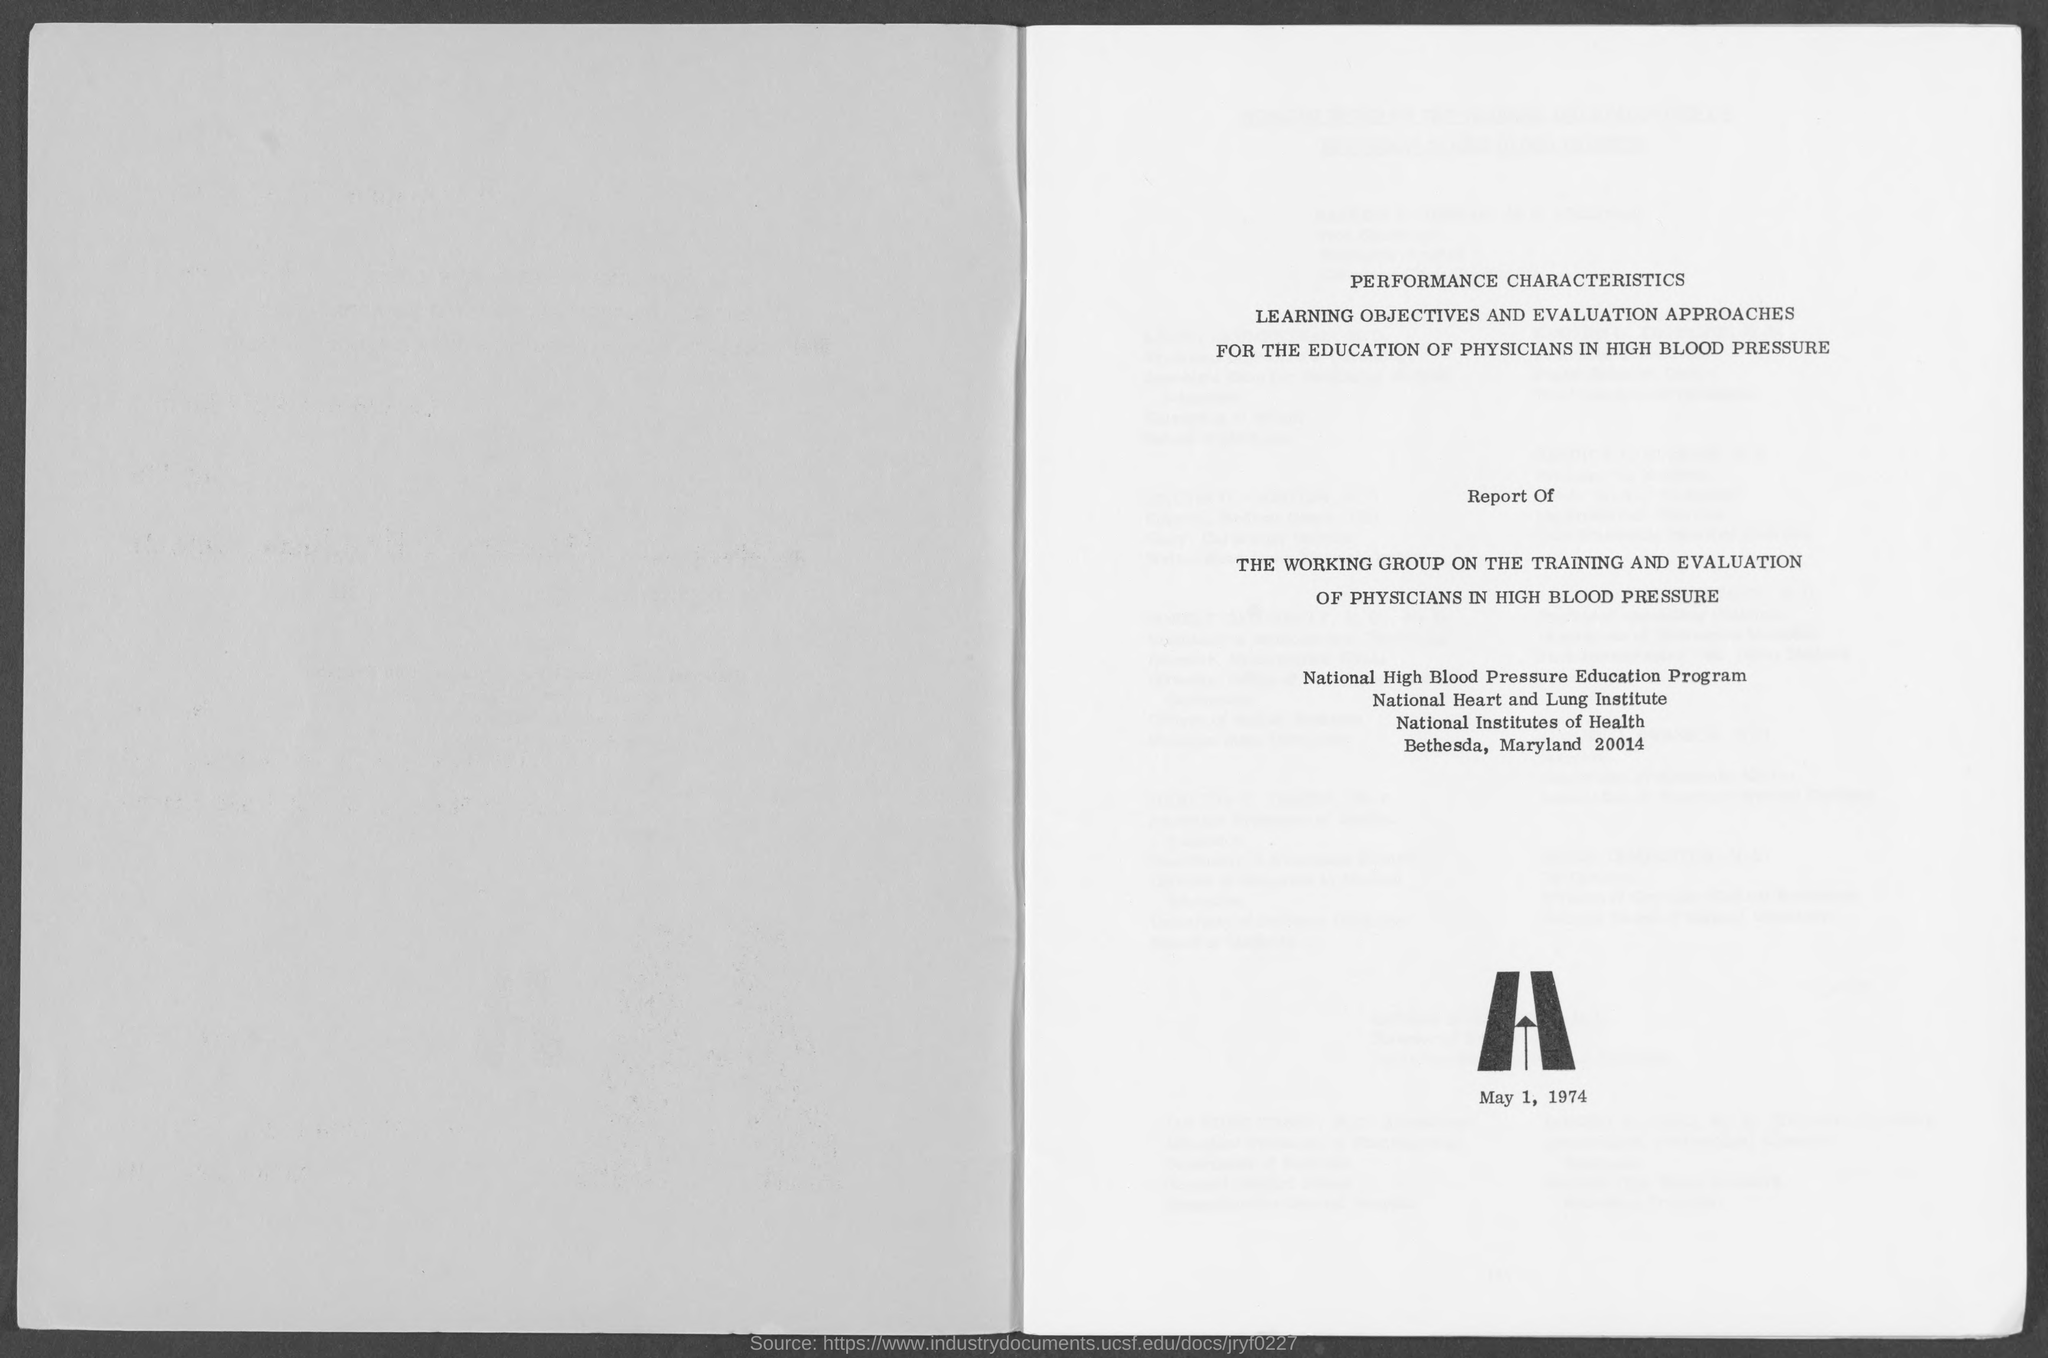What is the date in the document?
Your response must be concise. May 1, 1974. What is the name of the education program?
Your answer should be very brief. National High Blood Pressure Education Program. 